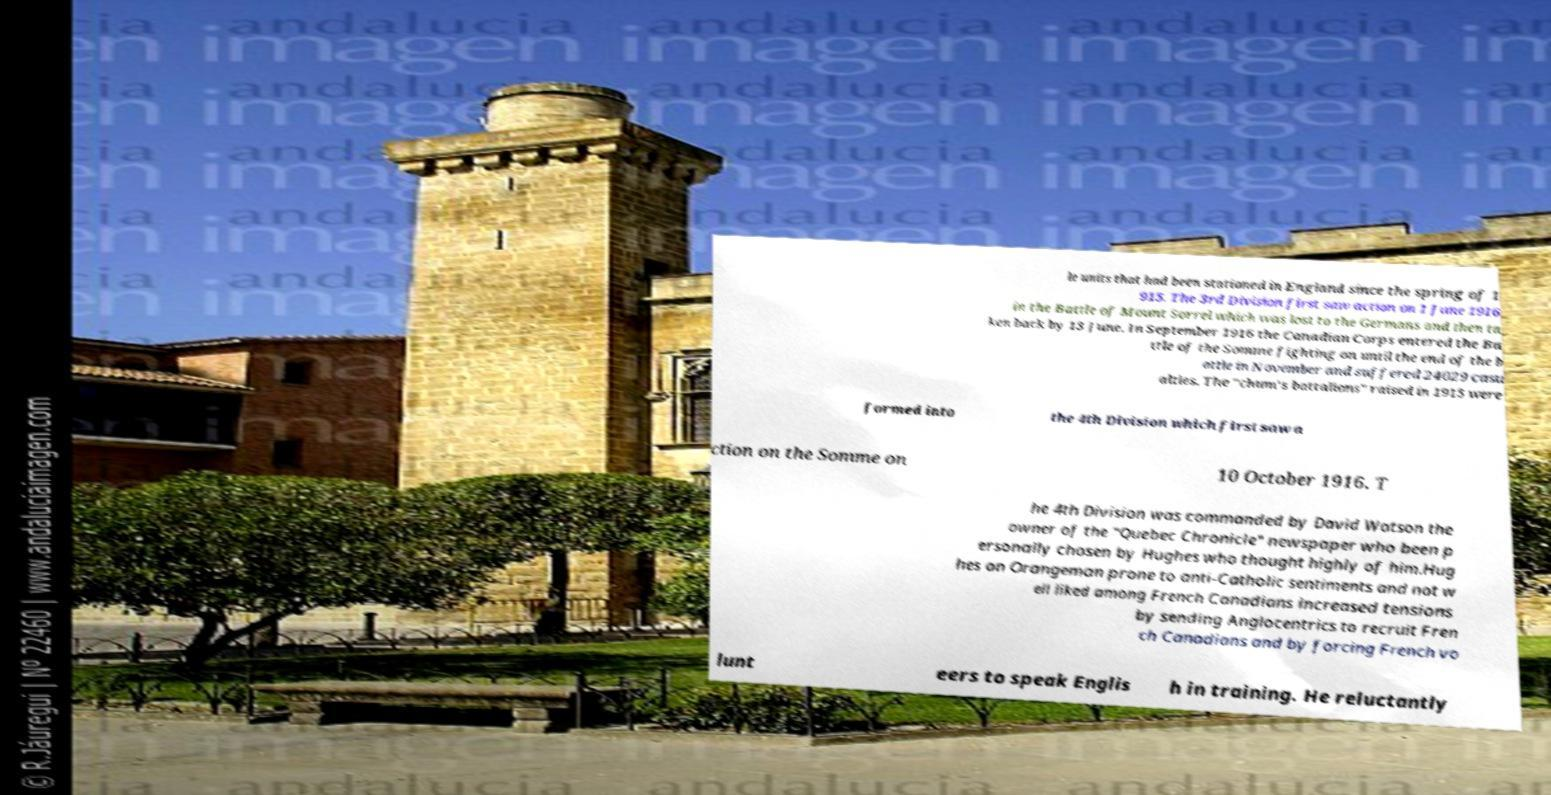Please read and relay the text visible in this image. What does it say? le units that had been stationed in England since the spring of 1 915. The 3rd Division first saw action on 1 June 1916 in the Battle of Mount Sorrel which was lost to the Germans and then ta ken back by 13 June. In September 1916 the Canadian Corps entered the Ba ttle of the Somme fighting on until the end of the b attle in November and suffered 24029 casu alties. The "chum's battalions" raised in 1915 were formed into the 4th Division which first saw a ction on the Somme on 10 October 1916. T he 4th Division was commanded by David Watson the owner of the "Quebec Chronicle" newspaper who been p ersonally chosen by Hughes who thought highly of him.Hug hes an Orangeman prone to anti-Catholic sentiments and not w ell liked among French Canadians increased tensions by sending Anglocentrics to recruit Fren ch Canadians and by forcing French vo lunt eers to speak Englis h in training. He reluctantly 